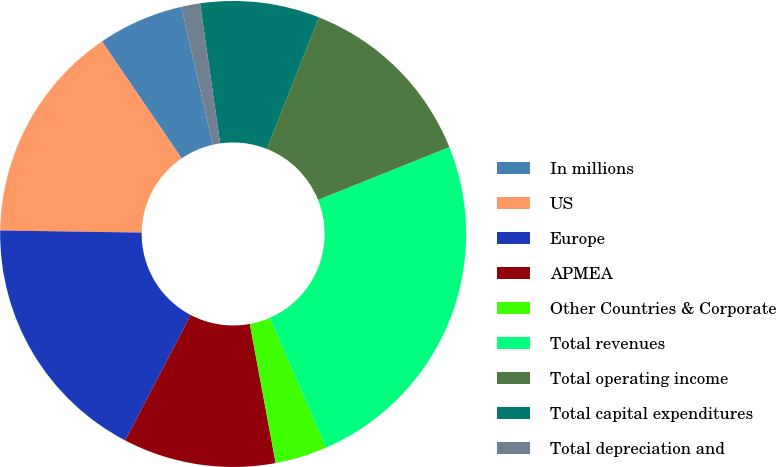Convert chart. <chart><loc_0><loc_0><loc_500><loc_500><pie_chart><fcel>In millions<fcel>US<fcel>Europe<fcel>APMEA<fcel>Other Countries & Corporate<fcel>Total revenues<fcel>Total operating income<fcel>Total capital expenditures<fcel>Total depreciation and<nl><fcel>5.95%<fcel>15.24%<fcel>17.57%<fcel>10.59%<fcel>3.62%<fcel>24.54%<fcel>12.92%<fcel>8.27%<fcel>1.3%<nl></chart> 